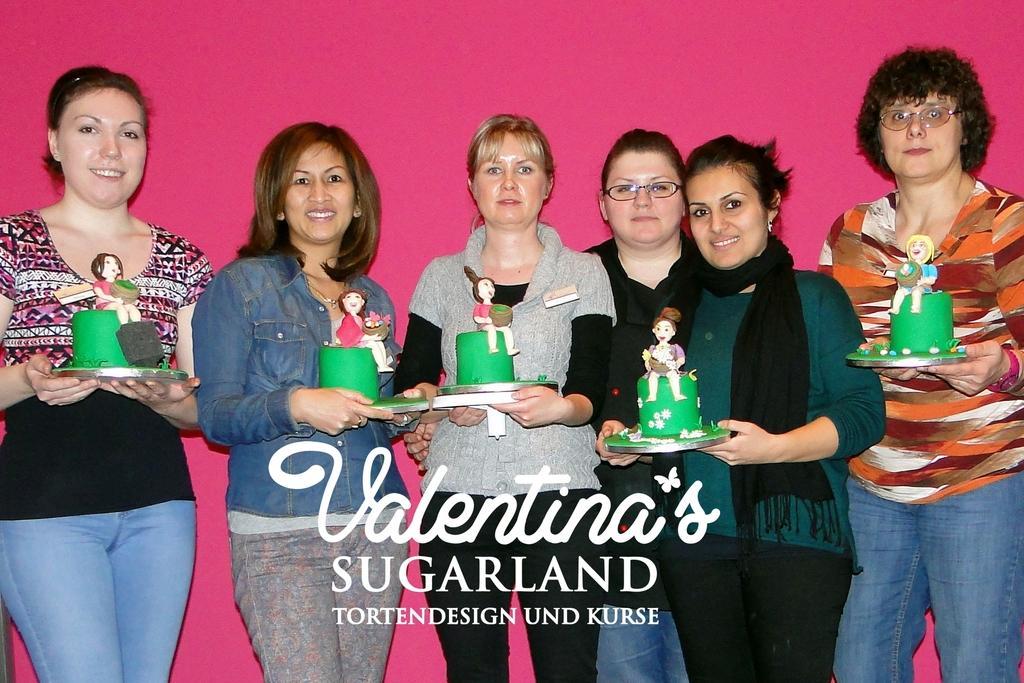Please provide a concise description of this image. In this image, we can see people wearing clothes and holding objects with their hands. There is a text at the bottom of the image. 